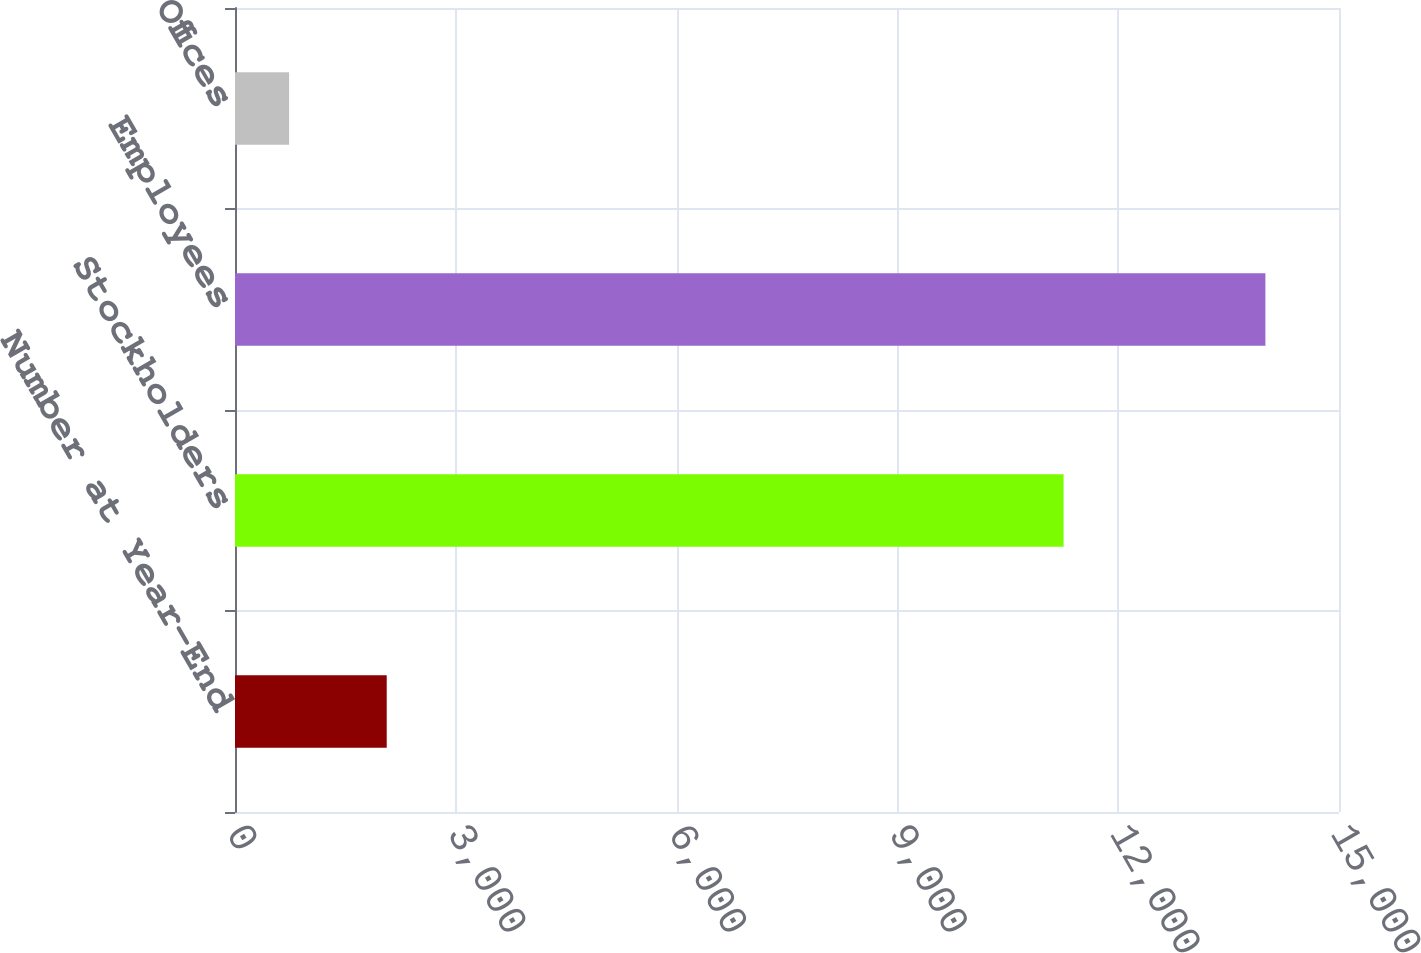Convert chart. <chart><loc_0><loc_0><loc_500><loc_500><bar_chart><fcel>Number at Year-End<fcel>Stockholders<fcel>Employees<fcel>Offices<nl><fcel>2061.5<fcel>11258<fcel>14000<fcel>735<nl></chart> 